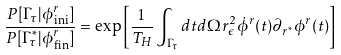Convert formula to latex. <formula><loc_0><loc_0><loc_500><loc_500>\frac { P [ \Gamma _ { \tau } | \phi ^ { r } _ { \text {ini} } ] } { P [ \Gamma ^ { \ast } _ { \tau } | \phi ^ { r } _ { \text {fin} } ] } = \exp \left [ \frac { 1 } { T _ { H } } \int _ { \Gamma _ { \tau } } d t d \Omega r _ { \epsilon } ^ { 2 } \dot { \phi } ^ { r } ( t ) \partial _ { r ^ { \ast } } \phi ^ { r } ( t ) \right ]</formula> 